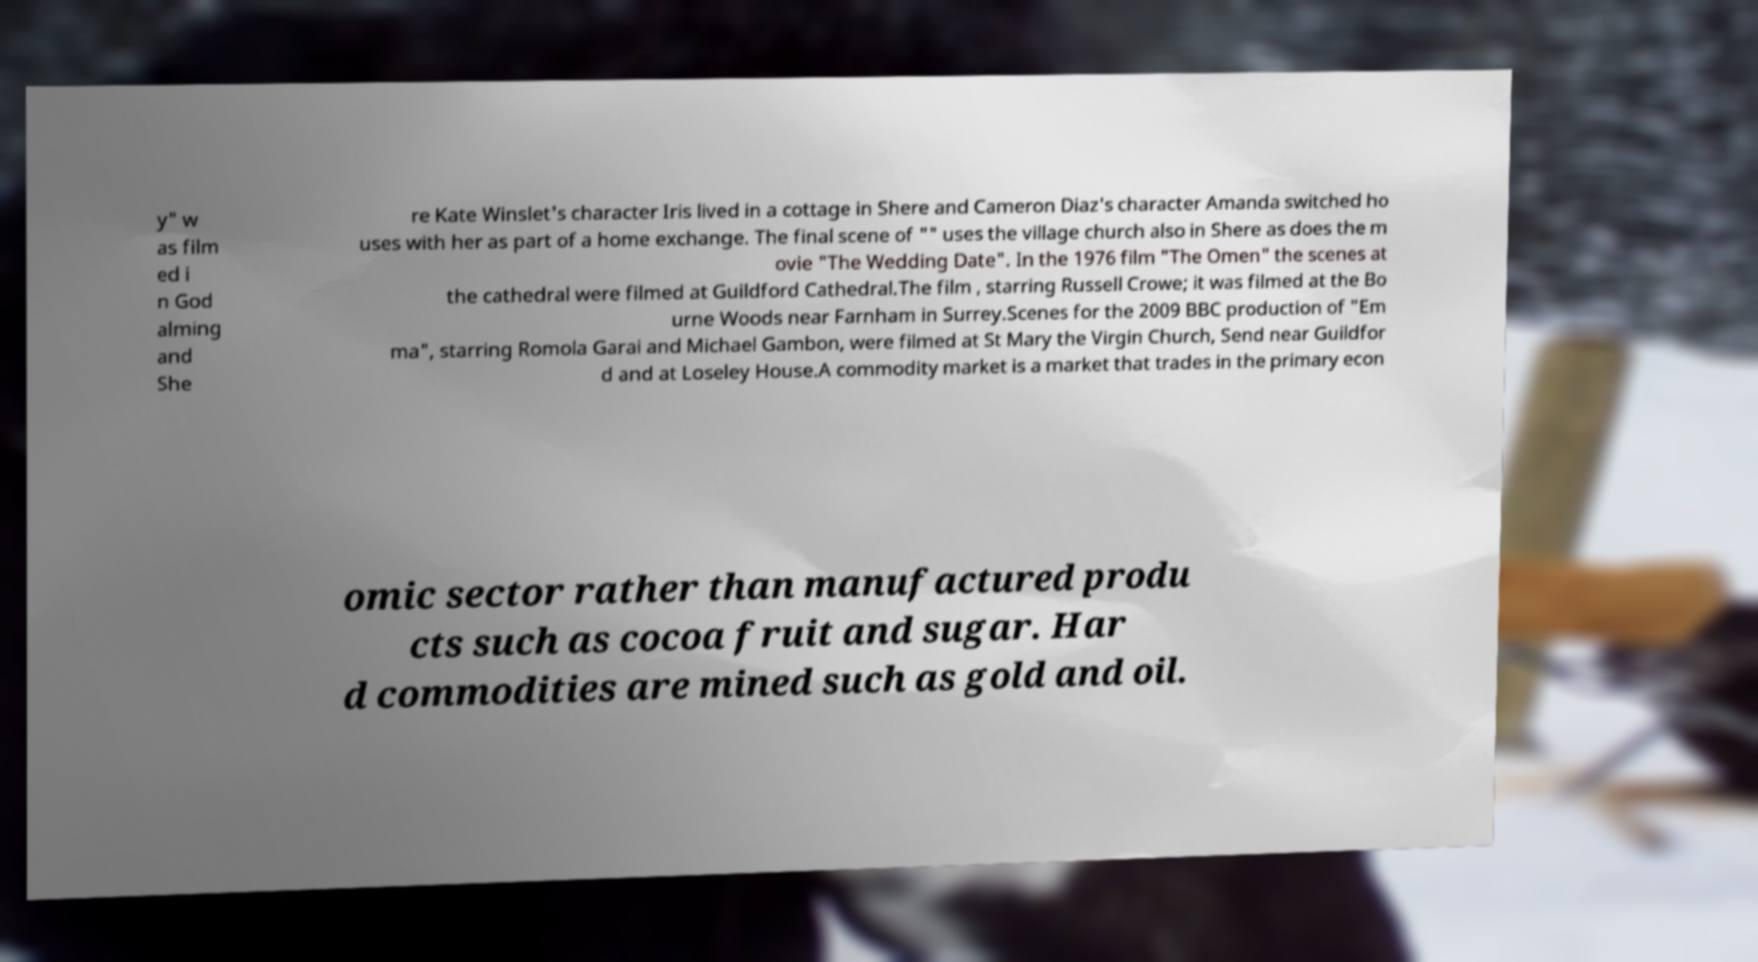Can you read and provide the text displayed in the image?This photo seems to have some interesting text. Can you extract and type it out for me? y" w as film ed i n God alming and She re Kate Winslet's character Iris lived in a cottage in Shere and Cameron Diaz's character Amanda switched ho uses with her as part of a home exchange. The final scene of "" uses the village church also in Shere as does the m ovie "The Wedding Date". In the 1976 film "The Omen" the scenes at the cathedral were filmed at Guildford Cathedral.The film , starring Russell Crowe; it was filmed at the Bo urne Woods near Farnham in Surrey.Scenes for the 2009 BBC production of "Em ma", starring Romola Garai and Michael Gambon, were filmed at St Mary the Virgin Church, Send near Guildfor d and at Loseley House.A commodity market is a market that trades in the primary econ omic sector rather than manufactured produ cts such as cocoa fruit and sugar. Har d commodities are mined such as gold and oil. 